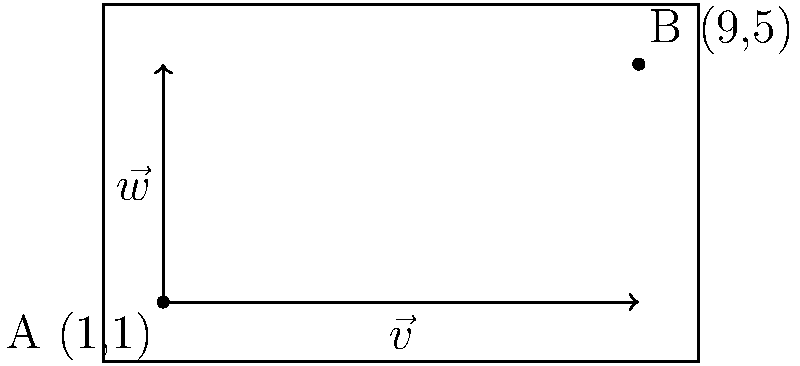In a video editing software, subtitles are initially positioned at point A(1,1) in the bottom-left corner of the screen. You need to move them to point B(9,5) in the top-right corner. Given the vectors $\vec{v} = (8,0)$ and $\vec{w} = (0,4)$, determine the vector that represents the translation from A to B using vector addition. To solve this problem, we'll follow these steps:

1) First, let's understand what the vectors represent:
   - $\vec{v} = (8,0)$ represents a horizontal movement to the right
   - $\vec{w} = (0,4)$ represents a vertical movement upward

2) We need to find a vector that moves from point A(1,1) to point B(9,5)

3) We can represent this movement as a combination of $\vec{v}$ and $\vec{w}$:
   $\vec{AB} = a\vec{v} + b\vec{w}$, where $a$ and $b$ are scalars

4) We know that:
   $\vec{AB} = (9-1, 5-1) = (8,4)$

5) Now, we can see that:
   $(8,4) = a(8,0) + b(0,4)$

6) This gives us:
   $8 = 8a$ and $4 = 4b$

7) Solving these equations:
   $a = 1$ and $b = 1$

8) Therefore, the translation vector is:
   $\vec{AB} = 1\vec{v} + 1\vec{w} = \vec{v} + \vec{w}$

9) In component form:
   $\vec{AB} = (8,0) + (0,4) = (8,4)$

This vector $(8,4)$ represents the translation from A to B, which can be achieved by adding $\vec{v}$ and $\vec{w}$.
Answer: $\vec{v} + \vec{w}$ or $(8,4)$ 